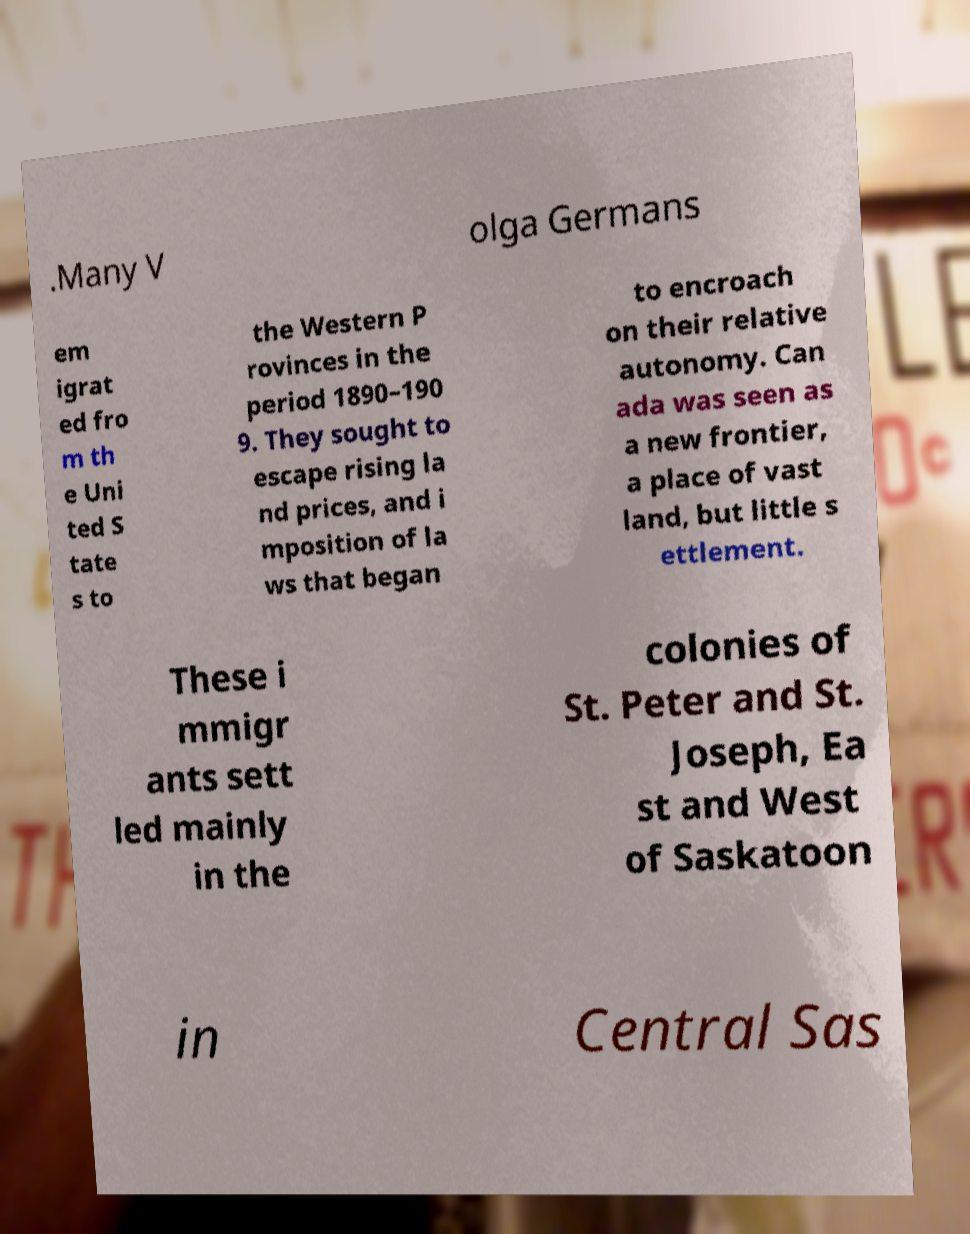Can you accurately transcribe the text from the provided image for me? .Many V olga Germans em igrat ed fro m th e Uni ted S tate s to the Western P rovinces in the period 1890–190 9. They sought to escape rising la nd prices, and i mposition of la ws that began to encroach on their relative autonomy. Can ada was seen as a new frontier, a place of vast land, but little s ettlement. These i mmigr ants sett led mainly in the colonies of St. Peter and St. Joseph, Ea st and West of Saskatoon in Central Sas 